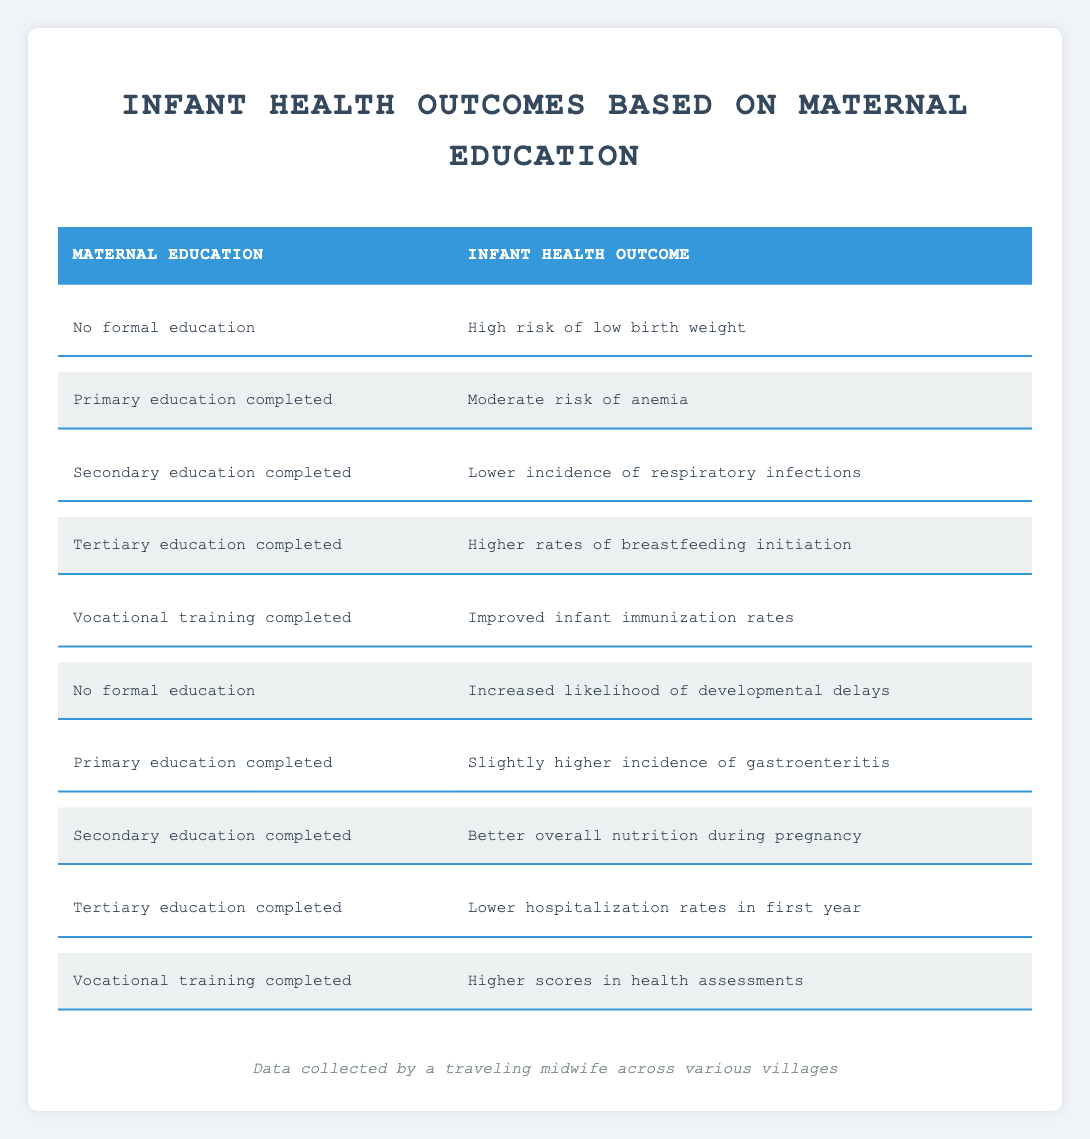What infant health outcome is associated with tertiary education completed? The corresponding row in the table states that for mothers with tertiary education completed, the infant health outcome is "Higher rates of breastfeeding initiation."
Answer: Higher rates of breastfeeding initiation Is there an infant health outcome associated with no formal education? Yes, the table lists two infant health outcomes for "No formal education": "High risk of low birth weight" and "Increased likelihood of developmental delays."
Answer: Yes What is the infant health outcome for mothers who have completed vocational training? According to the table, there are two outcomes for vocational training: "Improved infant immunization rates" and "Higher scores in health assessments."
Answer: Improved infant immunization rates, Higher scores in health assessments Which maternal education level has the lowest incidence of respiratory infections in infants? The table indicates that "Secondary education completed" is associated with "Lower incidence of respiratory infections," which suggests this level has the lowest incidence compared to others listed.
Answer: Secondary education completed Considering maternal education levels, which group has the highest risk regarding infant health outcomes? By examining the table, "No formal education" is linked to the highest risk outcomes: "High risk of low birth weight" and "Increased likelihood of developmental delays." Thus, it has the highest risk.
Answer: No formal education If you compare infants of mothers with primary education completed to those with secondary education completed, what are the key differences in health outcomes? For primary education completed, the health outcomes include "Moderate risk of anemia" and "Slightly higher incidence of gastroenteritis." For secondary education, the outcomes are "Lower incidence of respiratory infections" and "Better overall nutrition during pregnancy." Thus, secondary education leads to better health outcomes.
Answer: Key differences favor secondary education Are there any maternal education levels associated with better nutrition during pregnancy? Yes, the table shows that "Secondary education completed" is linked with "Better overall nutrition during pregnancy." Therefore, secondary education is associated with better nutrition.
Answer: Yes What is the health outcome difference between mothers with no formal education and those with tertiary education completed? The outcomes listed for "No formal education" are "High risk of low birth weight" and "Increased likelihood of developmental delays," whereas for "Tertiary education completed," the outcomes are "Higher rates of breastfeeding initiation" and "Lower hospitalization rates in the first year." The health outcomes for tertiary education are significantly more favorable.
Answer: Favorable outcomes in tertiary education What is the trend in infant health outcomes as maternal education increases? As maternal education increases, the outcomes improve: from high-risk and developmental issues associated with no education to better health practices and outcomes linked to tertiary education, such as increased breastfeeding and lower hospitalization rates.
Answer: Improvements with increased education 